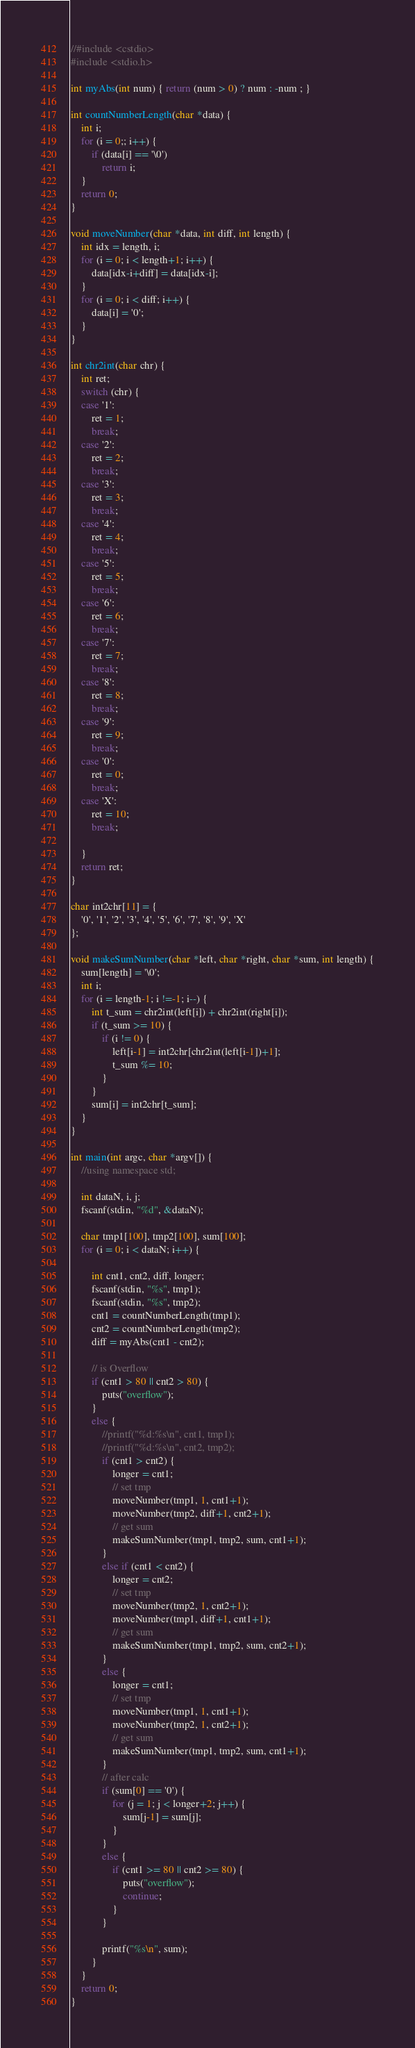<code> <loc_0><loc_0><loc_500><loc_500><_C_>//#include <cstdio>
#include <stdio.h>

int myAbs(int num) { return (num > 0) ? num : -num ; }

int countNumberLength(char *data) {
	int i;
	for (i = 0;; i++) {
		if (data[i] == '\0')
			return i;
	}
	return 0;
}

void moveNumber(char *data, int diff, int length) {
	int idx = length, i;
	for (i = 0; i < length+1; i++) {
		data[idx-i+diff] = data[idx-i];
	}
	for (i = 0; i < diff; i++) {
		data[i] = '0';
	}
}

int chr2int(char chr) {
	int ret;
	switch (chr) {
	case '1':
		ret = 1;
		break;
	case '2':
		ret = 2;
		break;
	case '3':
		ret = 3;
		break;
	case '4':
		ret = 4;
		break;
	case '5':
		ret = 5;
		break;
	case '6':
		ret = 6;
		break;
	case '7':
		ret = 7;
		break;
	case '8':
		ret = 8;
		break;
	case '9':
		ret = 9;
		break;
	case '0':
		ret = 0;
		break;
	case 'X':
		ret = 10;
		break;
	
	}
	return ret;
}

char int2chr[11] = {
	'0', '1', '2', '3', '4', '5', '6', '7', '8', '9', 'X'
};

void makeSumNumber(char *left, char *right, char *sum, int length) {
	sum[length] = '\0';
	int i;
	for (i = length-1; i !=-1; i--) {
		int t_sum = chr2int(left[i]) + chr2int(right[i]);
		if (t_sum >= 10) {
			if (i != 0) {
				left[i-1] = int2chr[chr2int(left[i-1])+1];
				t_sum %= 10;
			}
		}
		sum[i] = int2chr[t_sum];
	}
}

int main(int argc, char *argv[]) {
	//using namespace std;
	
	int dataN, i, j;
	fscanf(stdin, "%d", &dataN);
	
	char tmp1[100], tmp2[100], sum[100];
	for (i = 0; i < dataN; i++) {
		
		int cnt1, cnt2, diff, longer;
		fscanf(stdin, "%s", tmp1);
		fscanf(stdin, "%s", tmp2);
		cnt1 = countNumberLength(tmp1);
		cnt2 = countNumberLength(tmp2);
		diff = myAbs(cnt1 - cnt2);
		
		// is Overflow
		if (cnt1 > 80 || cnt2 > 80) {
			puts("overflow");
		}
		else {
			//printf("%d:%s\n", cnt1, tmp1);
			//printf("%d:%s\n", cnt2, tmp2);
			if (cnt1 > cnt2) {
				longer = cnt1;
				// set tmp
				moveNumber(tmp1, 1, cnt1+1);
				moveNumber(tmp2, diff+1, cnt2+1);
				// get sum
				makeSumNumber(tmp1, tmp2, sum, cnt1+1);
			}
			else if (cnt1 < cnt2) {
				longer = cnt2;
				// set tmp
				moveNumber(tmp2, 1, cnt2+1);
				moveNumber(tmp1, diff+1, cnt1+1);
				// get sum
				makeSumNumber(tmp1, tmp2, sum, cnt2+1);
			}
			else {
				longer = cnt1;
				// set tmp
				moveNumber(tmp1, 1, cnt1+1);
				moveNumber(tmp2, 1, cnt2+1);
				// get sum
				makeSumNumber(tmp1, tmp2, sum, cnt1+1);
			}
			// after calc
			if (sum[0] == '0') {
				for (j = 1; j < longer+2; j++) {
					sum[j-1] = sum[j];
				}
			}
			else {
				if (cnt1 >= 80 || cnt2 >= 80) {
					puts("overflow");
					continue;
				}
			}
			
			printf("%s\n", sum);
		}
	}
	return 0;
}</code> 